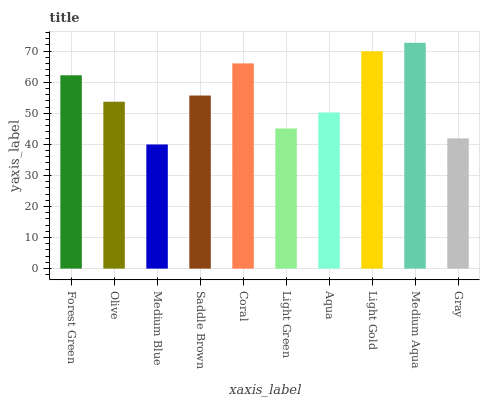Is Medium Blue the minimum?
Answer yes or no. Yes. Is Medium Aqua the maximum?
Answer yes or no. Yes. Is Olive the minimum?
Answer yes or no. No. Is Olive the maximum?
Answer yes or no. No. Is Forest Green greater than Olive?
Answer yes or no. Yes. Is Olive less than Forest Green?
Answer yes or no. Yes. Is Olive greater than Forest Green?
Answer yes or no. No. Is Forest Green less than Olive?
Answer yes or no. No. Is Saddle Brown the high median?
Answer yes or no. Yes. Is Olive the low median?
Answer yes or no. Yes. Is Gray the high median?
Answer yes or no. No. Is Medium Blue the low median?
Answer yes or no. No. 